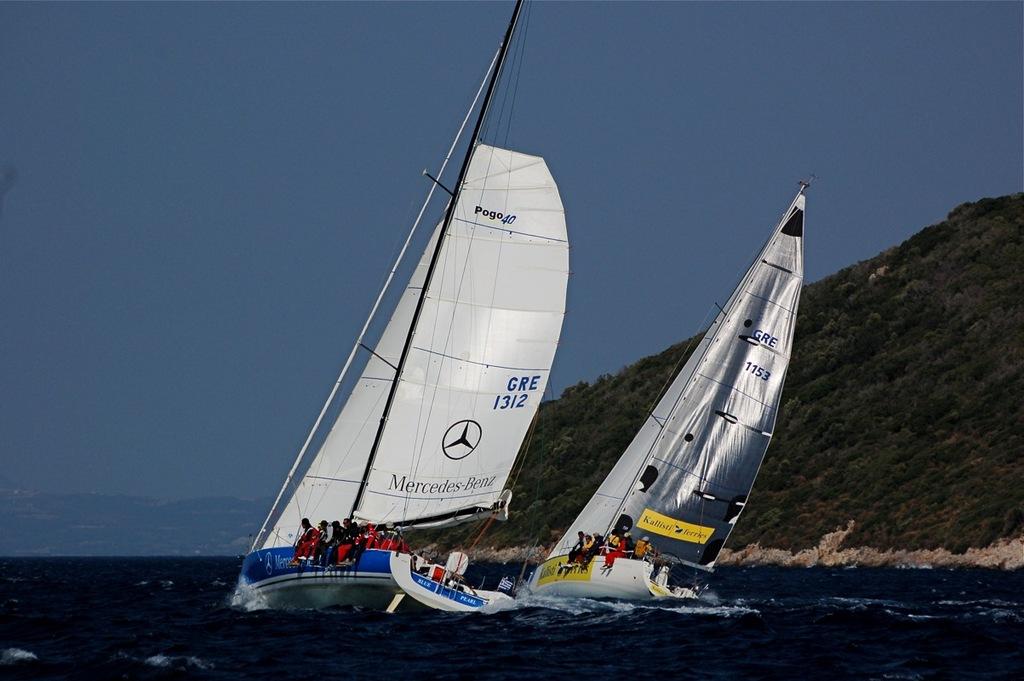Is the boat is really make by mercedes benz?
Give a very brief answer. Unanswerable. Who is sponsoring the boat?
Your answer should be very brief. Mercedes benz. 